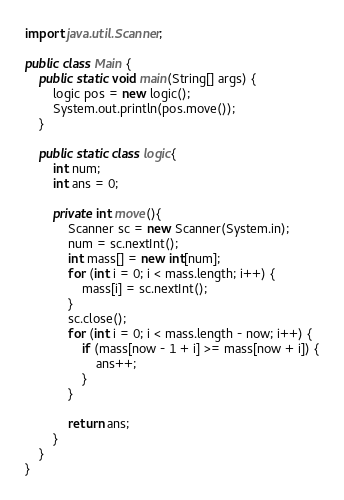Convert code to text. <code><loc_0><loc_0><loc_500><loc_500><_Java_>import java.util.Scanner;

public class Main {
    public static void main(String[] args) {
        logic pos = new logic();
        System.out.println(pos.move());
    }

    public static class logic{
        int num;
        int ans = 0;
        
        private int move(){
            Scanner sc = new Scanner(System.in);
            num = sc.nextInt();
            int mass[] = new int[num];
            for (int i = 0; i < mass.length; i++) {
                mass[i] = sc.nextInt();
            }
            sc.close();
            for (int i = 0; i < mass.length - now; i++) {
                if (mass[now - 1 + i] >= mass[now + i]) {
                    ans++;
                }
            }
            
            return ans;
        }
    }
}</code> 